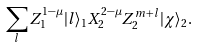Convert formula to latex. <formula><loc_0><loc_0><loc_500><loc_500>\sum _ { l } Z _ { 1 } ^ { 1 - \mu } | l \rangle _ { 1 } X _ { 2 } ^ { 2 - \mu } Z _ { 2 } ^ { m + l } | \chi \rangle _ { 2 } .</formula> 